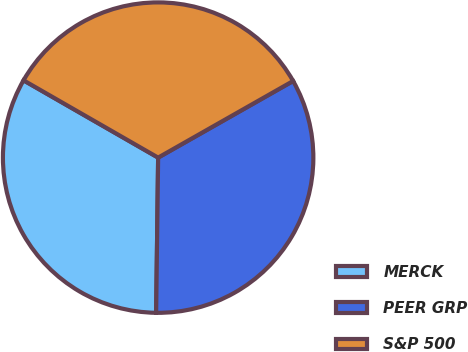Convert chart. <chart><loc_0><loc_0><loc_500><loc_500><pie_chart><fcel>MERCK<fcel>PEER GRP<fcel>S&P 500<nl><fcel>33.09%<fcel>33.42%<fcel>33.49%<nl></chart> 